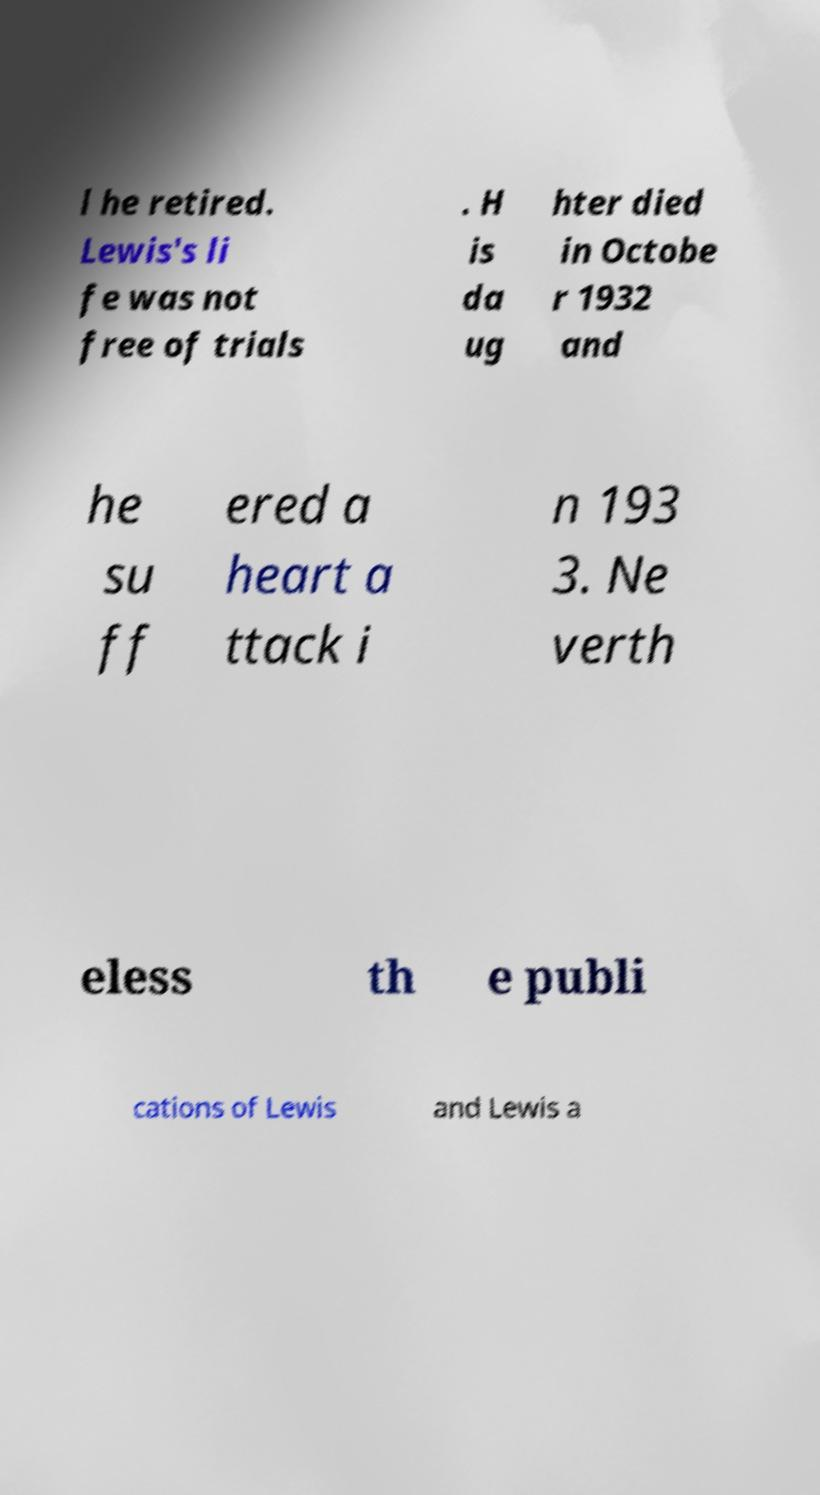For documentation purposes, I need the text within this image transcribed. Could you provide that? l he retired. Lewis's li fe was not free of trials . H is da ug hter died in Octobe r 1932 and he su ff ered a heart a ttack i n 193 3. Ne verth eless th e publi cations of Lewis and Lewis a 